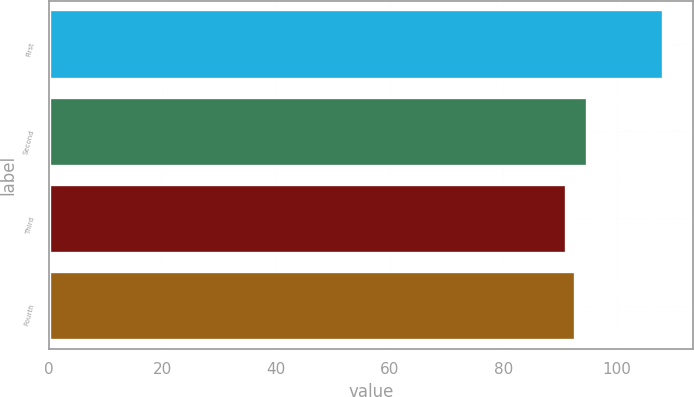<chart> <loc_0><loc_0><loc_500><loc_500><bar_chart><fcel>First<fcel>Second<fcel>Third<fcel>Fourth<nl><fcel>108.07<fcel>94.74<fcel>91.02<fcel>92.72<nl></chart> 